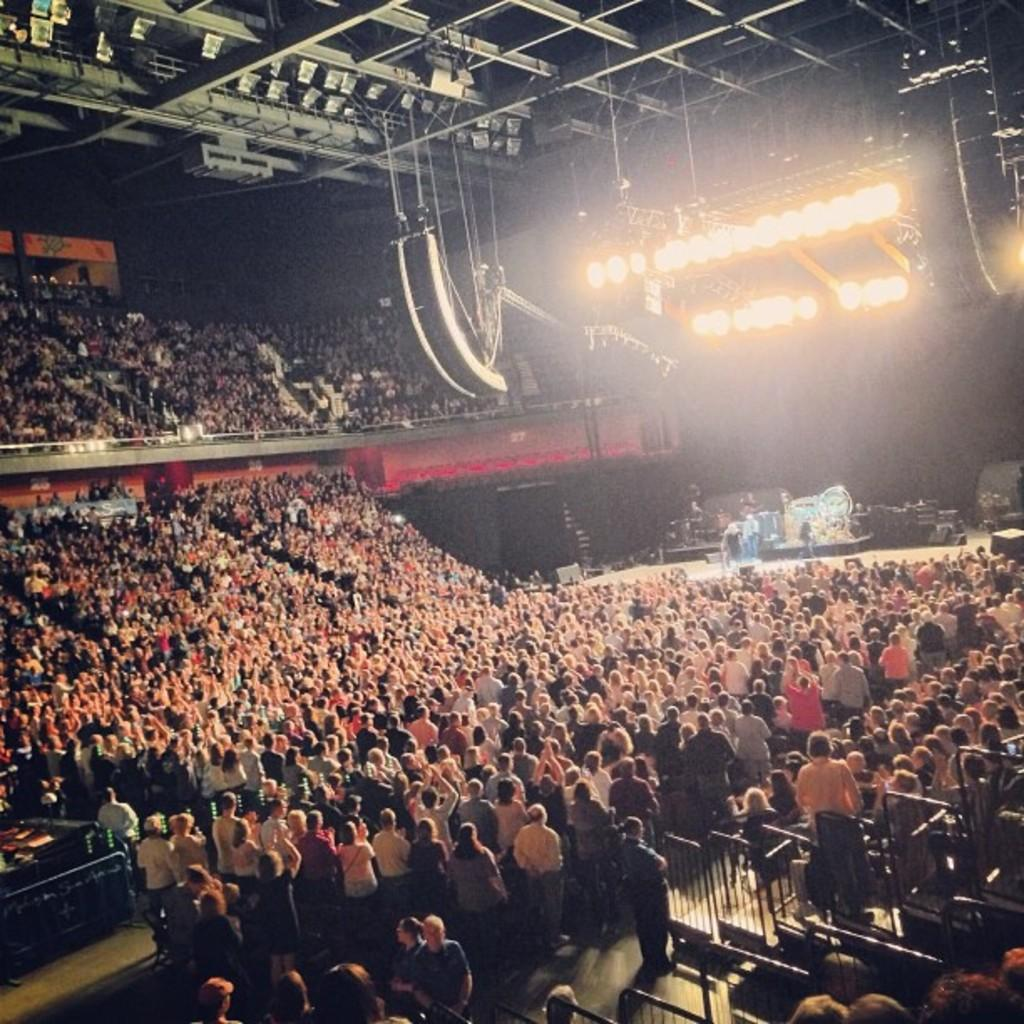How many individuals are present in the image? There are many people in the image. What are the people in the image doing? The people are standing together. What can be seen on the ceiling in the image? There are lights visible on the ceiling. What type of star can be seen in the image? There is no star visible in the image; it features a group of people standing together with lights on the ceiling. What is the creator of the people in the image? The image is a photograph or illustration, and the people are not created beings; they are real individuals. 